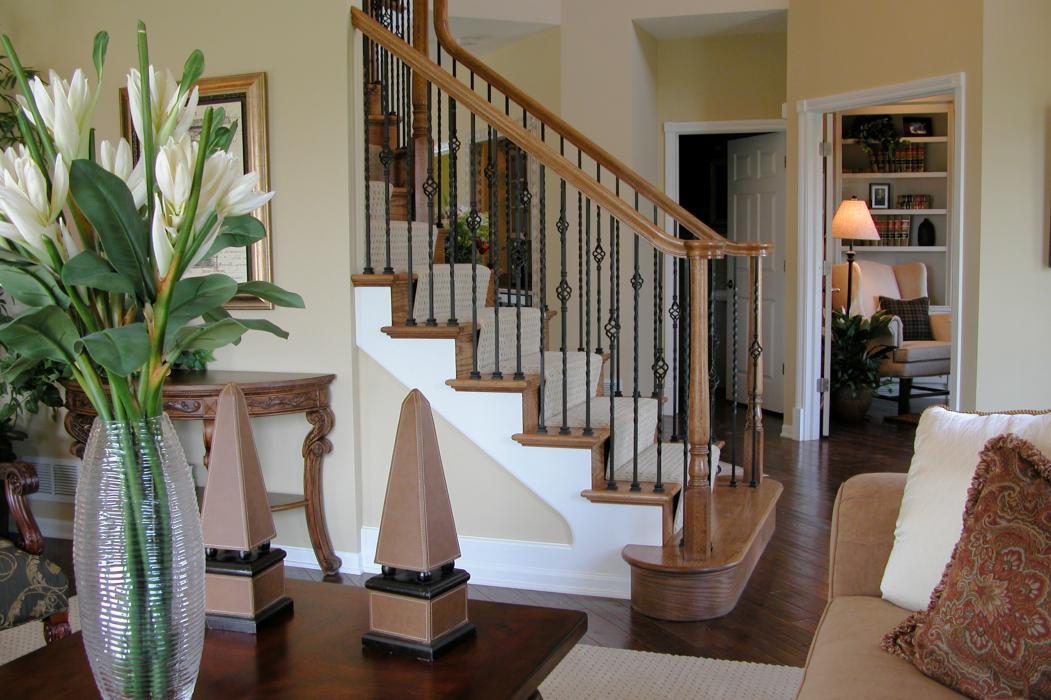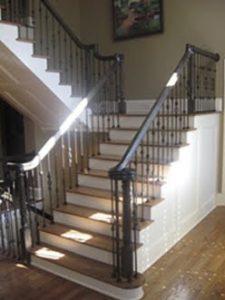The first image is the image on the left, the second image is the image on the right. Evaluate the accuracy of this statement regarding the images: "The right image shows a curving staircase with brown steps and white baseboards, a curving brown rail, and black wrought iron bars.". Is it true? Answer yes or no. No. The first image is the image on the left, the second image is the image on the right. Examine the images to the left and right. Is the description "In at least one image there is  a set of stairs point left forward with the bottom step longer than the rest." accurate? Answer yes or no. Yes. 